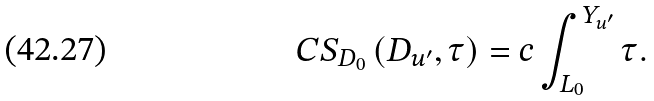Convert formula to latex. <formula><loc_0><loc_0><loc_500><loc_500>C S _ { D _ { 0 } } \left ( D _ { u ^ { \prime } } , \tau \right ) = c \int \nolimits _ { L _ { 0 } } ^ { Y _ { u ^ { \prime } } } \tau .</formula> 